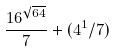<formula> <loc_0><loc_0><loc_500><loc_500>\frac { 1 6 ^ { \sqrt { 6 4 } } } { 7 } + ( 4 ^ { 1 } / 7 )</formula> 